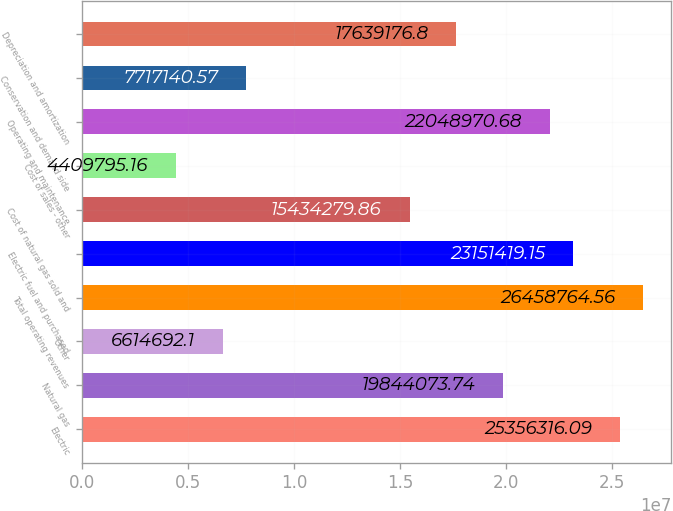Convert chart. <chart><loc_0><loc_0><loc_500><loc_500><bar_chart><fcel>Electric<fcel>Natural gas<fcel>Other<fcel>Total operating revenues<fcel>Electric fuel and purchased<fcel>Cost of natural gas sold and<fcel>Cost of sales - other<fcel>Operating and maintenance<fcel>Conservation and demand side<fcel>Depreciation and amortization<nl><fcel>2.53563e+07<fcel>1.98441e+07<fcel>6.61469e+06<fcel>2.64588e+07<fcel>2.31514e+07<fcel>1.54343e+07<fcel>4.4098e+06<fcel>2.2049e+07<fcel>7.71714e+06<fcel>1.76392e+07<nl></chart> 